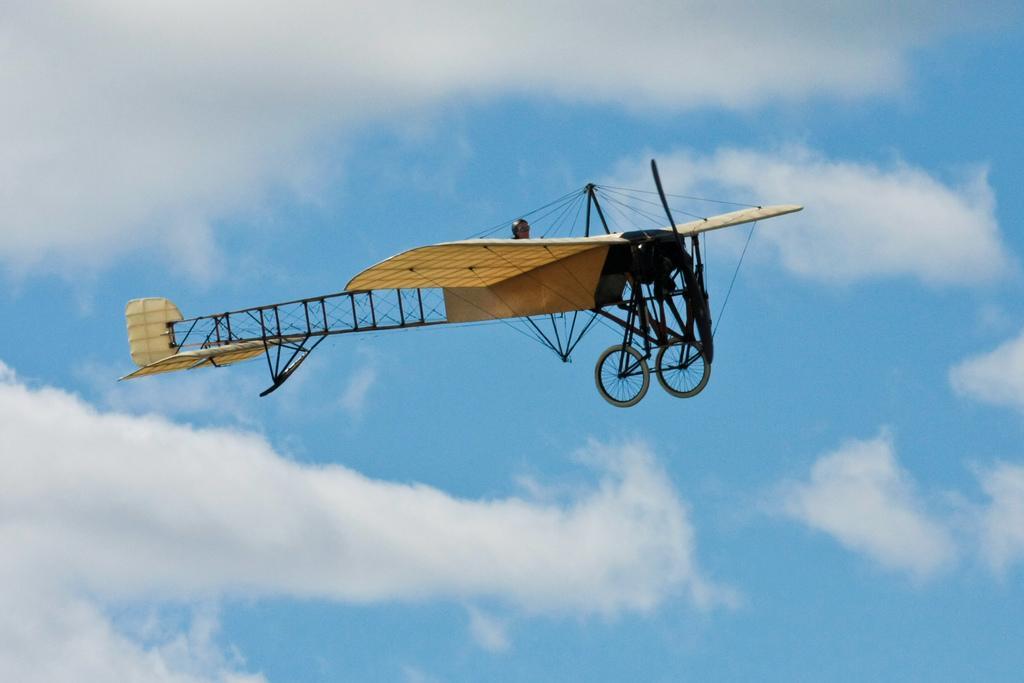How would you summarize this image in a sentence or two? In this picture there is a monoplane in the sky and there is a person sitting in the monoplane. At the top there is sky and there are clouds. 